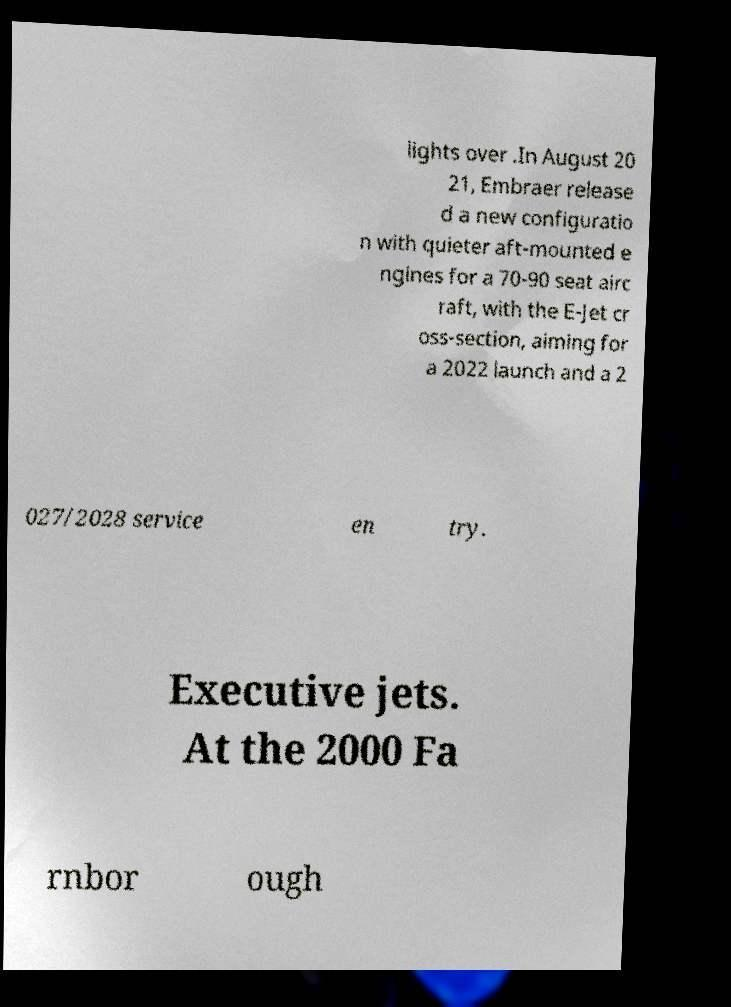Could you assist in decoding the text presented in this image and type it out clearly? lights over .In August 20 21, Embraer release d a new configuratio n with quieter aft-mounted e ngines for a 70-90 seat airc raft, with the E-Jet cr oss-section, aiming for a 2022 launch and a 2 027/2028 service en try. Executive jets. At the 2000 Fa rnbor ough 